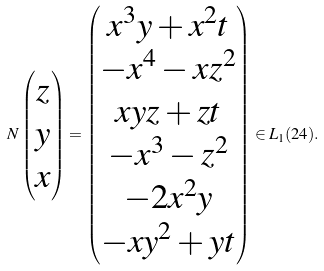Convert formula to latex. <formula><loc_0><loc_0><loc_500><loc_500>N \begin{pmatrix} z \\ y \\ x \end{pmatrix} = \begin{pmatrix} x ^ { 3 } y + x ^ { 2 } t \\ - x ^ { 4 } - x z ^ { 2 } \\ x y z + z t \\ - x ^ { 3 } - z ^ { 2 } \\ - 2 x ^ { 2 } y \\ - x y ^ { 2 } + y t \end{pmatrix} \in L _ { 1 } ( 2 4 ) .</formula> 